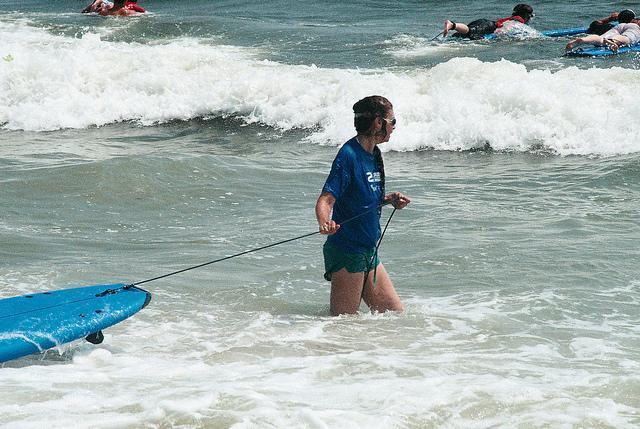How many cats are lying down?
Give a very brief answer. 0. 